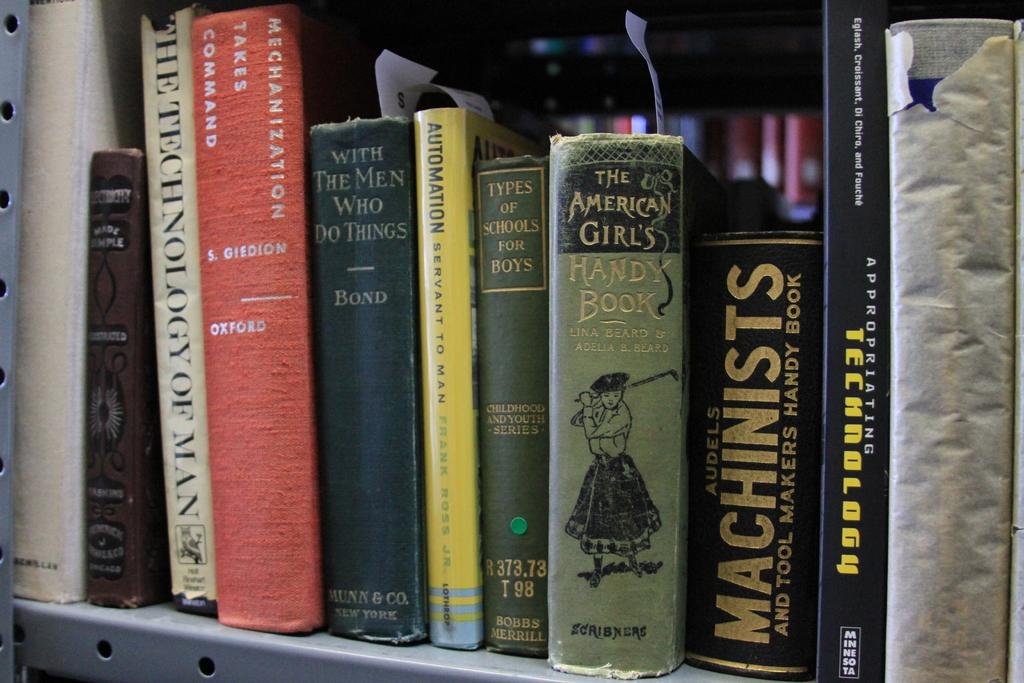Provide a one-sentence caption for the provided image. Several book titles on a shelf including The American Girls HANDY BOOK. 